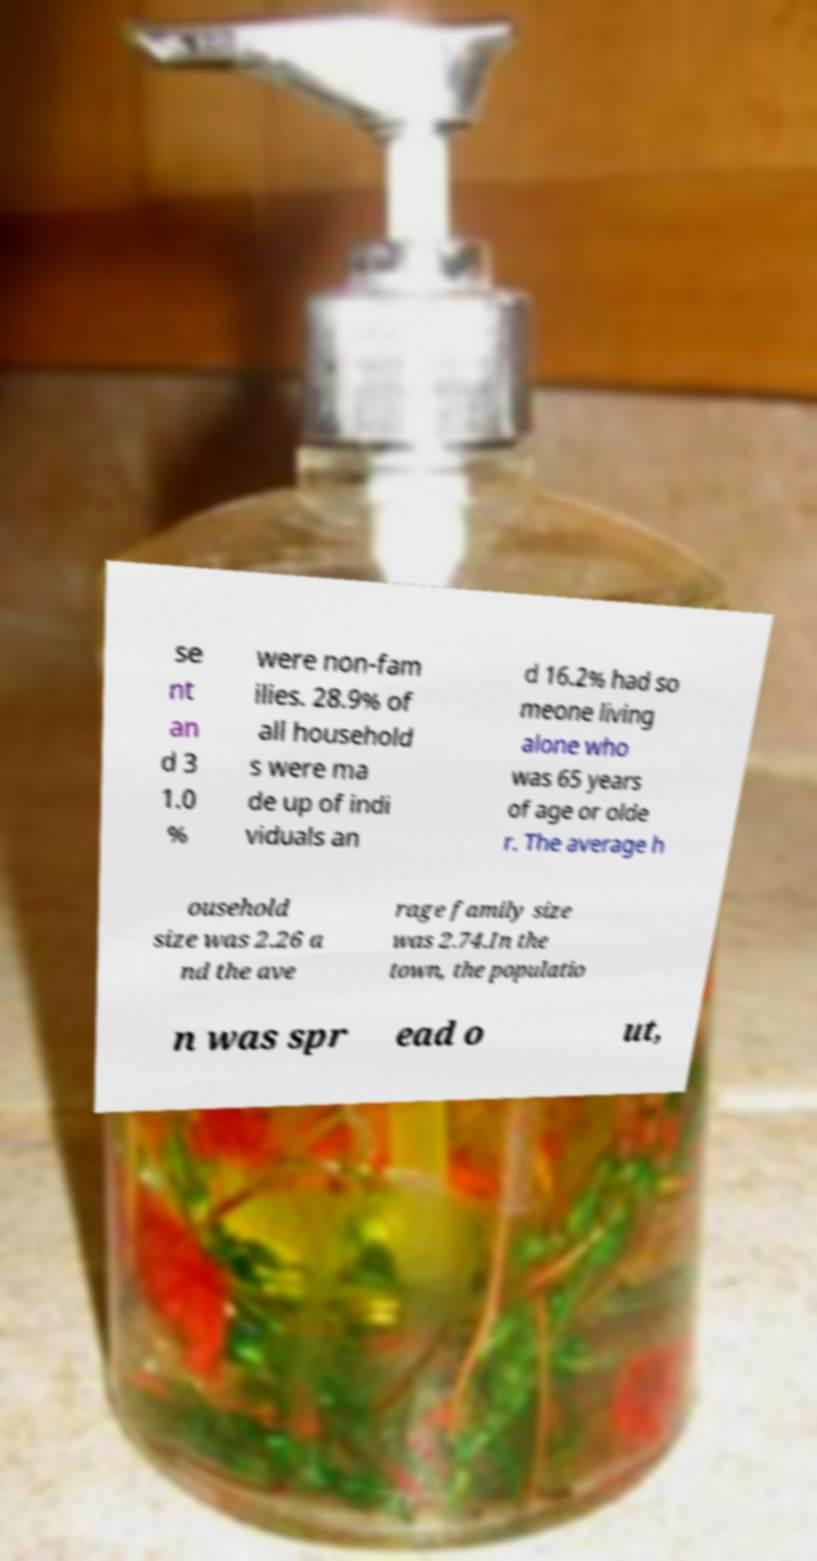For documentation purposes, I need the text within this image transcribed. Could you provide that? se nt an d 3 1.0 % were non-fam ilies. 28.9% of all household s were ma de up of indi viduals an d 16.2% had so meone living alone who was 65 years of age or olde r. The average h ousehold size was 2.26 a nd the ave rage family size was 2.74.In the town, the populatio n was spr ead o ut, 